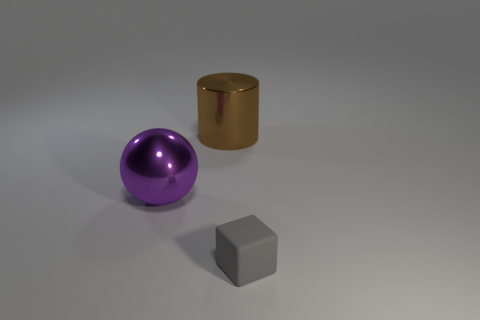Add 2 large metal spheres. How many objects exist? 5 Subtract all balls. How many objects are left? 2 Add 2 tiny brown cylinders. How many tiny brown cylinders exist? 2 Subtract 1 brown cylinders. How many objects are left? 2 Subtract all large purple shiny objects. Subtract all purple shiny spheres. How many objects are left? 1 Add 3 spheres. How many spheres are left? 4 